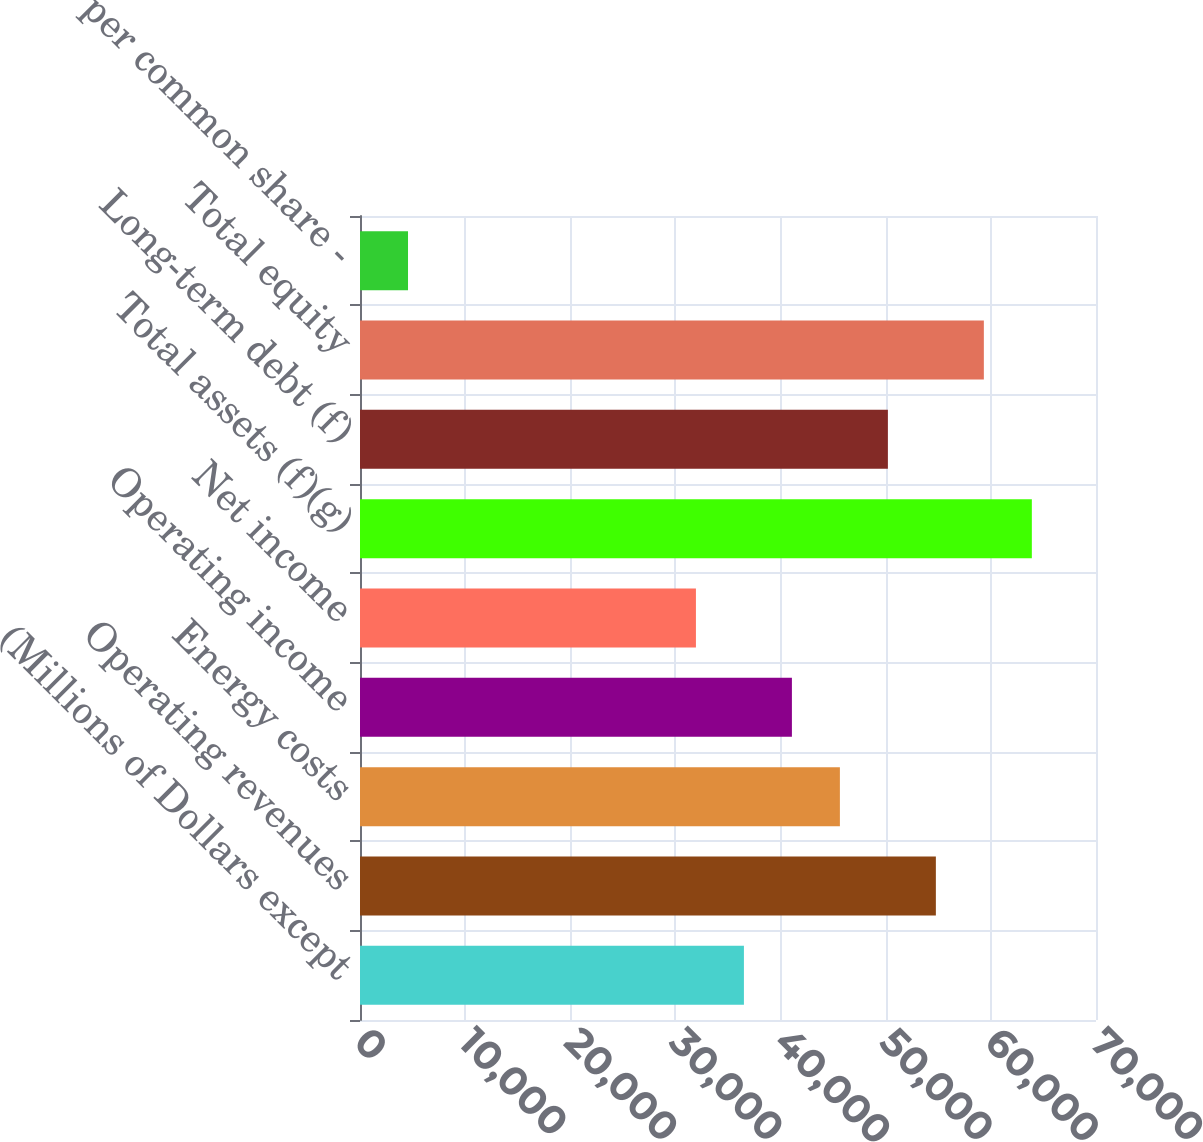Convert chart to OTSL. <chart><loc_0><loc_0><loc_500><loc_500><bar_chart><fcel>(Millions of Dollars except<fcel>Operating revenues<fcel>Energy costs<fcel>Operating income<fcel>Net income<fcel>Total assets (f)(g)<fcel>Long-term debt (f)<fcel>Total equity<fcel>Net Income per common share -<nl><fcel>36514.1<fcel>54769.9<fcel>45642<fcel>41078.1<fcel>31950.2<fcel>63897.8<fcel>50205.9<fcel>59333.8<fcel>4566.54<nl></chart> 